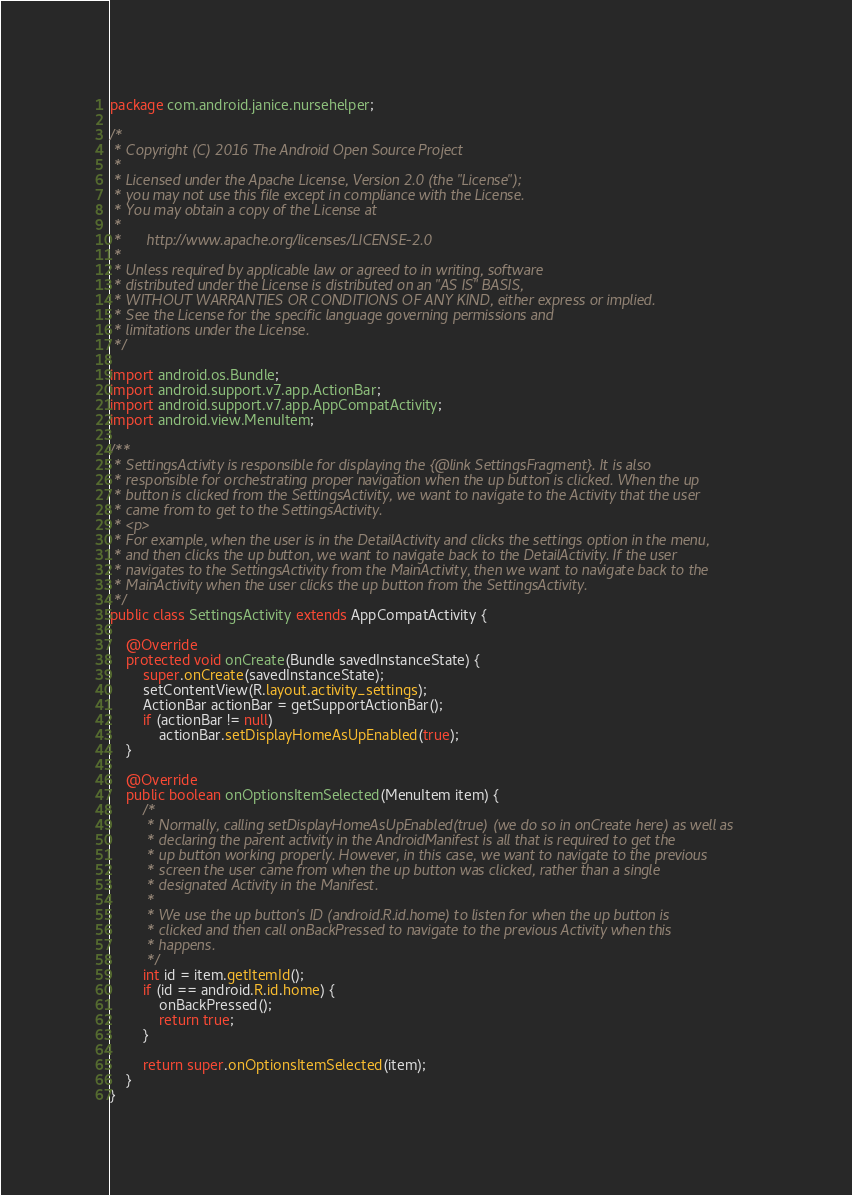<code> <loc_0><loc_0><loc_500><loc_500><_Java_>package com.android.janice.nursehelper;

/*
 * Copyright (C) 2016 The Android Open Source Project
 *
 * Licensed under the Apache License, Version 2.0 (the "License");
 * you may not use this file except in compliance with the License.
 * You may obtain a copy of the License at
 *
 *      http://www.apache.org/licenses/LICENSE-2.0
 *
 * Unless required by applicable law or agreed to in writing, software
 * distributed under the License is distributed on an "AS IS" BASIS,
 * WITHOUT WARRANTIES OR CONDITIONS OF ANY KIND, either express or implied.
 * See the License for the specific language governing permissions and
 * limitations under the License.
 */

import android.os.Bundle;
import android.support.v7.app.ActionBar;
import android.support.v7.app.AppCompatActivity;
import android.view.MenuItem;

/**
 * SettingsActivity is responsible for displaying the {@link SettingsFragment}. It is also
 * responsible for orchestrating proper navigation when the up button is clicked. When the up
 * button is clicked from the SettingsActivity, we want to navigate to the Activity that the user
 * came from to get to the SettingsActivity.
 * <p>
 * For example, when the user is in the DetailActivity and clicks the settings option in the menu,
 * and then clicks the up button, we want to navigate back to the DetailActivity. If the user
 * navigates to the SettingsActivity from the MainActivity, then we want to navigate back to the
 * MainActivity when the user clicks the up button from the SettingsActivity.
 */
public class SettingsActivity extends AppCompatActivity {

    @Override
    protected void onCreate(Bundle savedInstanceState) {
        super.onCreate(savedInstanceState);
        setContentView(R.layout.activity_settings);
        ActionBar actionBar = getSupportActionBar();
        if (actionBar != null)
            actionBar.setDisplayHomeAsUpEnabled(true);
    }

    @Override
    public boolean onOptionsItemSelected(MenuItem item) {
        /*
         * Normally, calling setDisplayHomeAsUpEnabled(true) (we do so in onCreate here) as well as
         * declaring the parent activity in the AndroidManifest is all that is required to get the
         * up button working properly. However, in this case, we want to navigate to the previous
         * screen the user came from when the up button was clicked, rather than a single
         * designated Activity in the Manifest.
         *
         * We use the up button's ID (android.R.id.home) to listen for when the up button is
         * clicked and then call onBackPressed to navigate to the previous Activity when this
         * happens.
         */
        int id = item.getItemId();
        if (id == android.R.id.home) {
            onBackPressed();
            return true;
        }

        return super.onOptionsItemSelected(item);
    }
}
</code> 